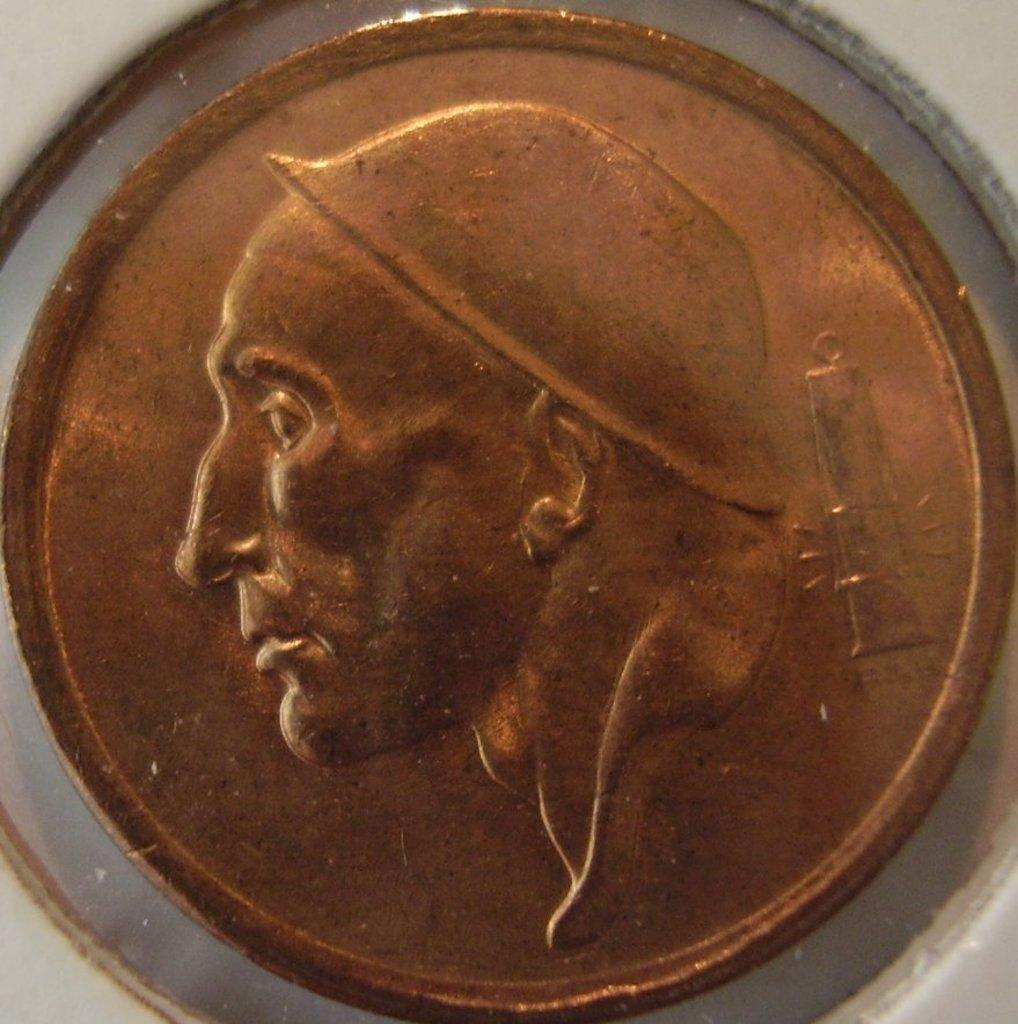What object is the main focus of the image? There is a coin in the image. What is depicted on the coin? The coin has an image of a person on it. What is the color of the surface the coin is placed on? The coin is placed on a white surface. What type of apparel is the person wearing in the image? There is no person present in the image, only a coin with an image of a person on it. What part of the person's body is visible in the image? Since there is no person present in the image, we cannot determine any visible body parts. 